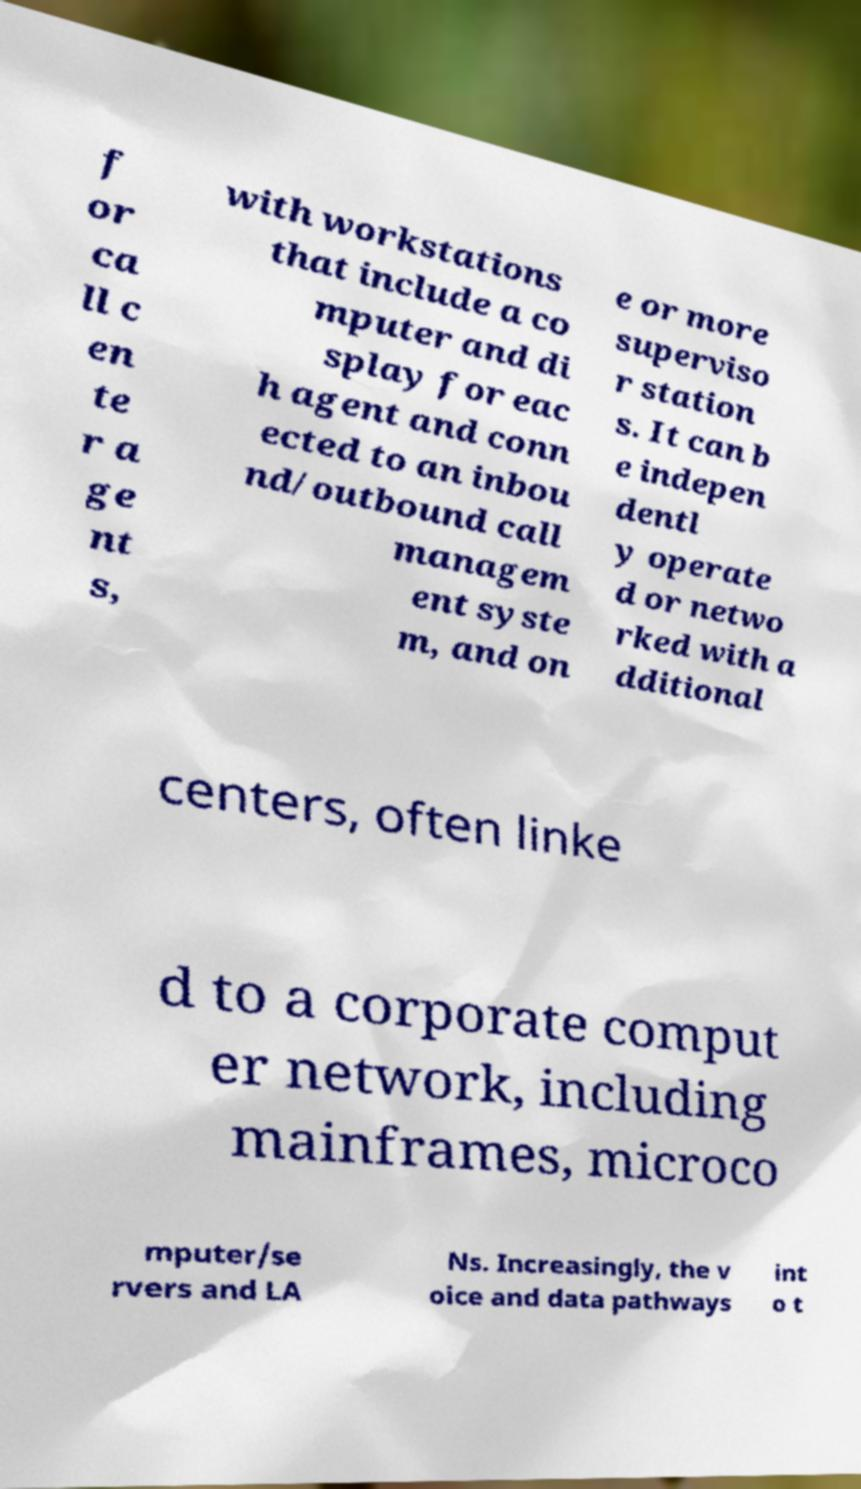There's text embedded in this image that I need extracted. Can you transcribe it verbatim? f or ca ll c en te r a ge nt s, with workstations that include a co mputer and di splay for eac h agent and conn ected to an inbou nd/outbound call managem ent syste m, and on e or more superviso r station s. It can b e indepen dentl y operate d or netwo rked with a dditional centers, often linke d to a corporate comput er network, including mainframes, microco mputer/se rvers and LA Ns. Increasingly, the v oice and data pathways int o t 